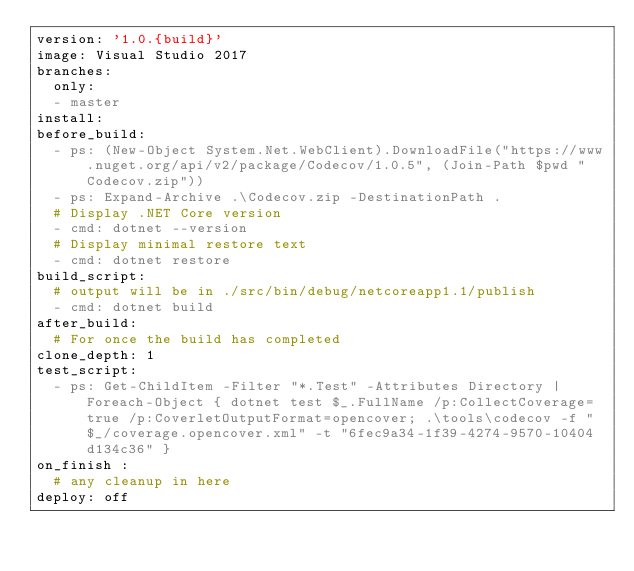Convert code to text. <code><loc_0><loc_0><loc_500><loc_500><_YAML_>version: '1.0.{build}'
image: Visual Studio 2017
branches:
  only:
  - master
install:
before_build:
  - ps: (New-Object System.Net.WebClient).DownloadFile("https://www.nuget.org/api/v2/package/Codecov/1.0.5", (Join-Path $pwd "Codecov.zip"))
  - ps: Expand-Archive .\Codecov.zip -DestinationPath .
  # Display .NET Core version
  - cmd: dotnet --version
  # Display minimal restore text
  - cmd: dotnet restore
build_script:
  # output will be in ./src/bin/debug/netcoreapp1.1/publish
  - cmd: dotnet build
after_build:
  # For once the build has completed
clone_depth: 1
test_script:
  - ps: Get-ChildItem -Filter "*.Test" -Attributes Directory | Foreach-Object { dotnet test $_.FullName /p:CollectCoverage=true /p:CoverletOutputFormat=opencover; .\tools\codecov -f "$_/coverage.opencover.xml" -t "6fec9a34-1f39-4274-9570-10404d134c36" }
on_finish :
  # any cleanup in here
deploy: off</code> 